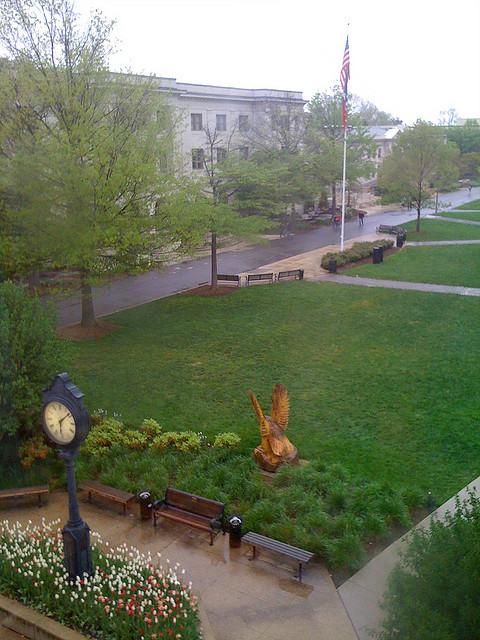What is the man-made object sticking out of the flower garden?
Answer briefly. Clock. Is there a rabbit in the park?
Keep it brief. No. What is the weather scene?
Answer briefly. Cloudy. 